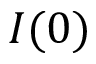<formula> <loc_0><loc_0><loc_500><loc_500>I ( 0 )</formula> 